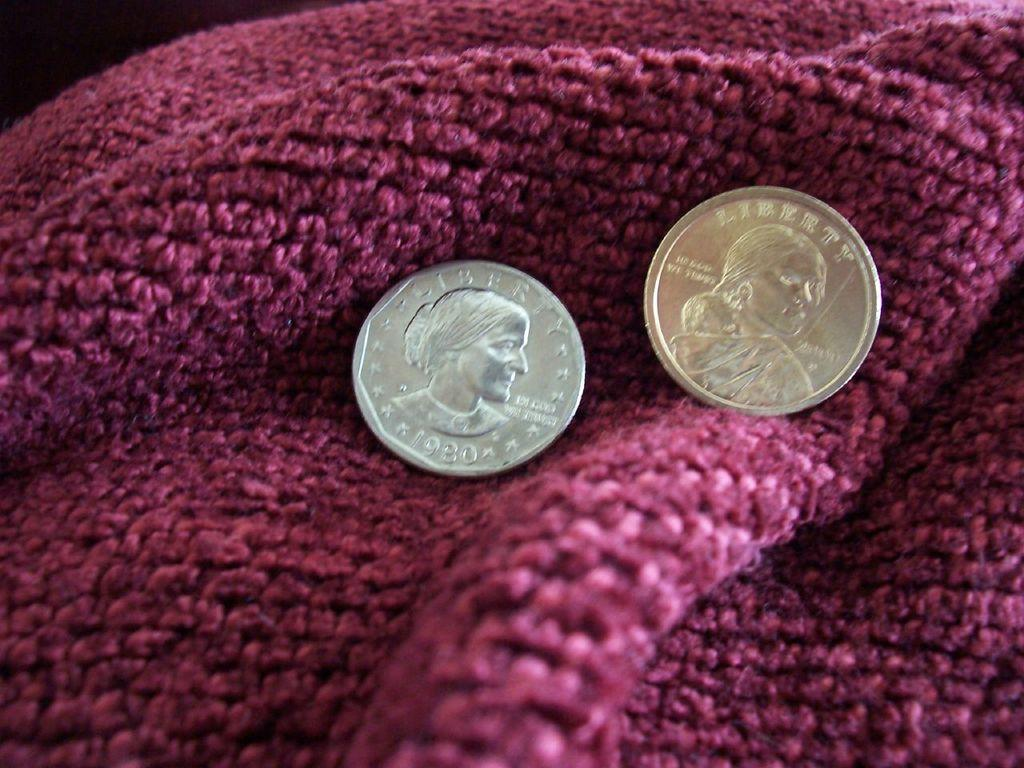Provide a one-sentence caption for the provided image. Two coins with the word Liberty written on them are displayed on a red blanket. 